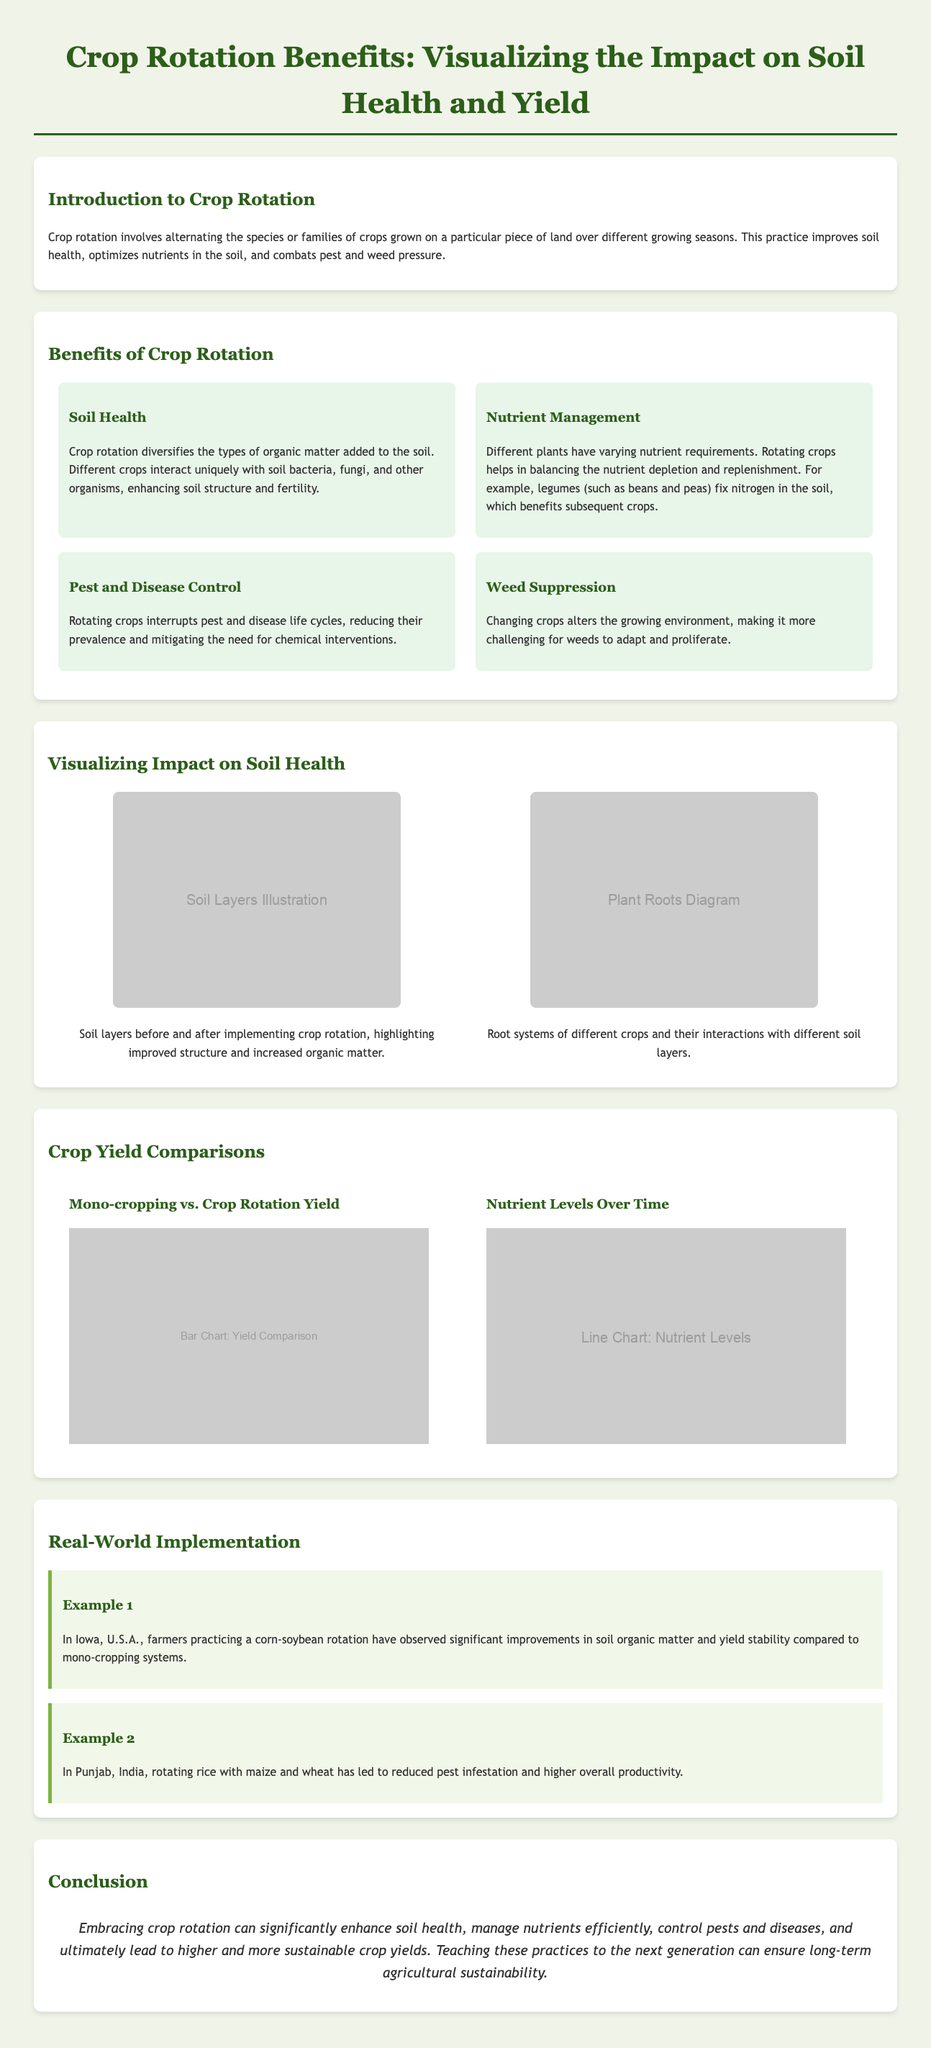what is crop rotation? Crop rotation involves alternating the species or families of crops grown on a particular piece of land over different growing seasons.
Answer: alternating species or families of crops what are the four benefits of crop rotation listed? The infographic highlights soil health, nutrient management, pest and disease control, and weed suppression as benefits of crop rotation.
Answer: soil health, nutrient management, pest and disease control, weed suppression which crop is an example of a legume? The document suggests that beans and peas are examples of legumes that fix nitrogen in the soil.
Answer: beans and peas what illustration is used to show soil layers? The infographic uses an image labeled "Soil Layers Illustration" to depict soil layers before and after crop rotation.
Answer: Soil Layers Illustration how do crop rotations affect pest control? Rotating crops interrupts pest and disease life cycles, reducing their prevalence and mitigating the need for chemical interventions.
Answer: interrupts pest and disease life cycles what improvement was observed in Iowa from crop rotation? Iowa farmers practicing corn-soybean rotation noted significant improvements in soil organic matter and yield stability.
Answer: improved soil organic matter and yield stability what comparison is shown in the charts? The charts compare mono-cropping vs. crop rotation yield and nutrient levels over time.
Answer: mono-cropping vs. crop rotation yield and nutrient levels what is the conclusion about crop rotation? The conclusion emphasizes that embracing crop rotation enhances soil health, manages nutrients efficiently, controls pests, and leads to sustainable crop yields.
Answer: enhances soil health, manages nutrients efficiently, controls pests, sustainable crop yields 